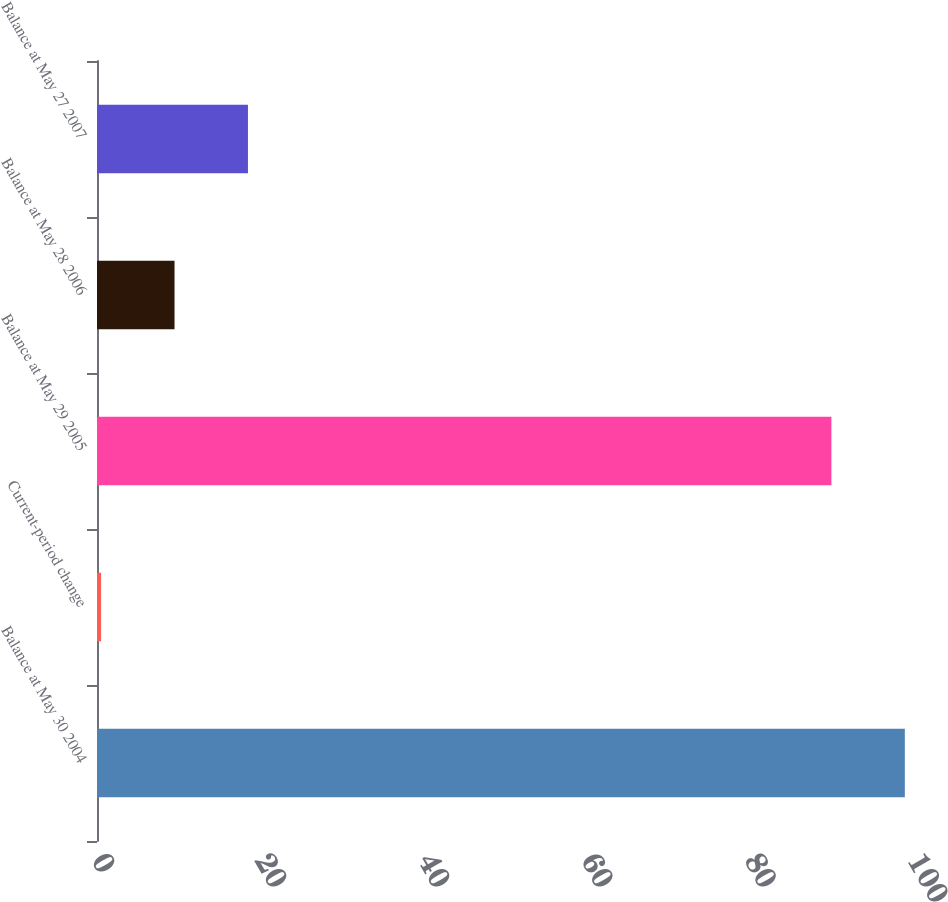<chart> <loc_0><loc_0><loc_500><loc_500><bar_chart><fcel>Balance at May 30 2004<fcel>Current-period change<fcel>Balance at May 29 2005<fcel>Balance at May 28 2006<fcel>Balance at May 27 2007<nl><fcel>99<fcel>0.5<fcel>90<fcel>9.5<fcel>18.5<nl></chart> 